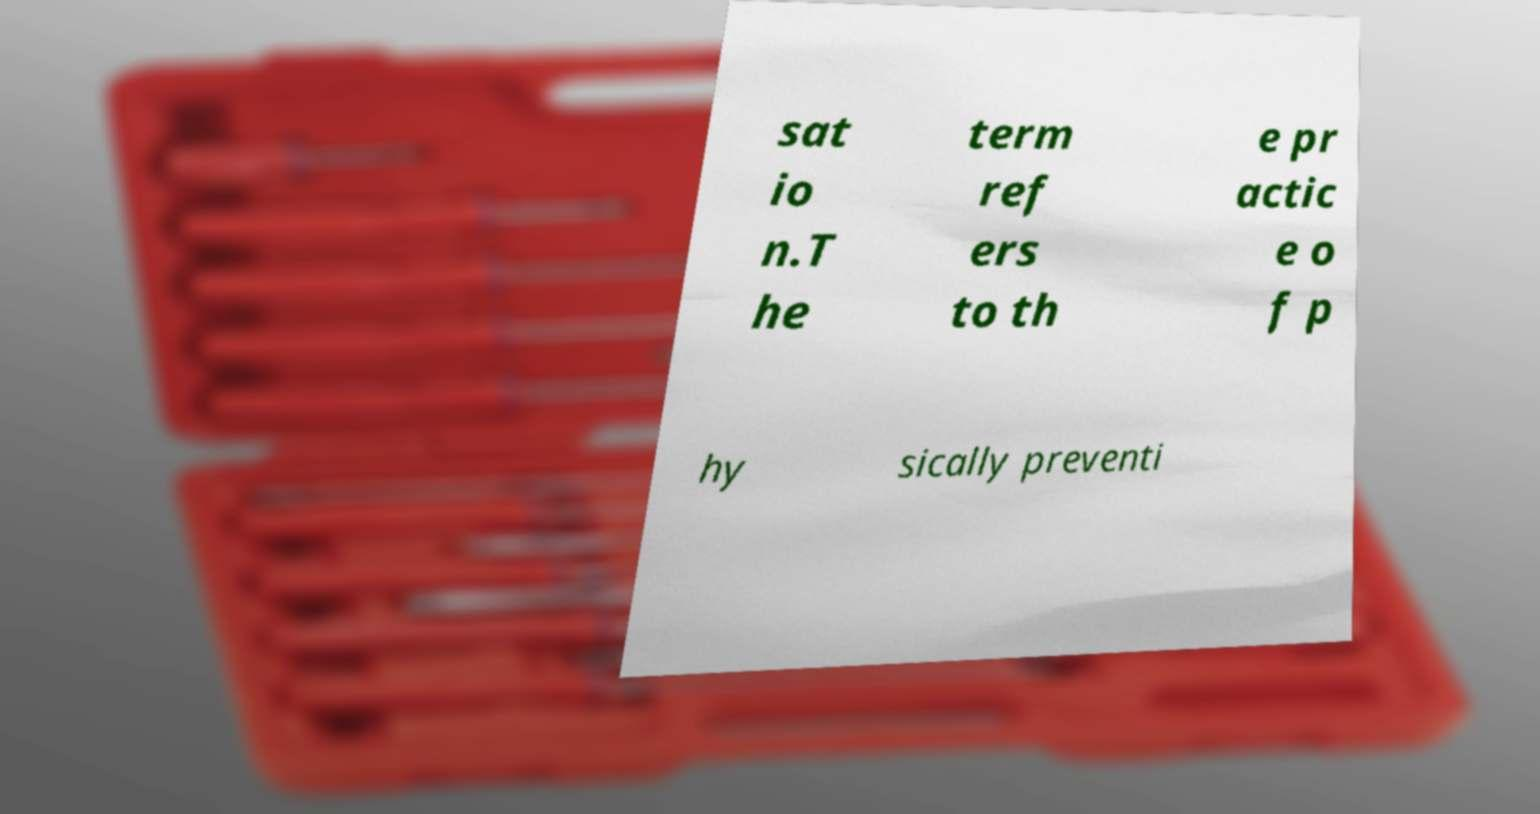I need the written content from this picture converted into text. Can you do that? sat io n.T he term ref ers to th e pr actic e o f p hy sically preventi 